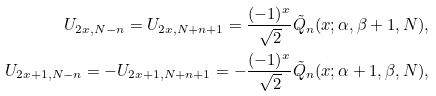Convert formula to latex. <formula><loc_0><loc_0><loc_500><loc_500>U _ { 2 x , N - n } = U _ { 2 x , N + n + 1 } = \frac { ( - 1 ) ^ { x } } { \sqrt { 2 } } \tilde { Q } _ { n } ( x ; \alpha , \beta + 1 , N ) , \\ U _ { 2 x + 1 , N - n } = - U _ { 2 x + 1 , N + n + 1 } = - \frac { ( - 1 ) ^ { x } } { \sqrt { 2 } } \tilde { Q } _ { n } ( x ; \alpha + 1 , \beta , N ) ,</formula> 